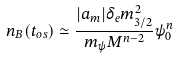<formula> <loc_0><loc_0><loc_500><loc_500>n _ { B } ( t _ { o s } ) \simeq \frac { | a _ { m } | \delta _ { e } m _ { 3 / 2 } ^ { 2 } } { m _ { \psi } M ^ { n - 2 } } \psi _ { 0 } ^ { n }</formula> 